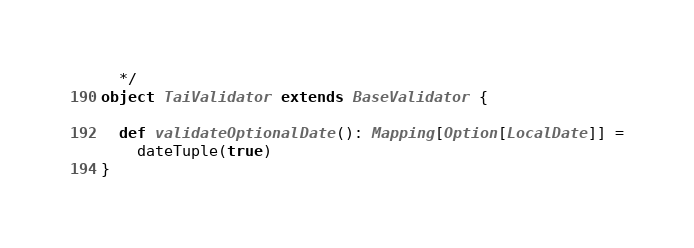Convert code to text. <code><loc_0><loc_0><loc_500><loc_500><_Scala_>  */
object TaiValidator extends BaseValidator {

  def validateOptionalDate(): Mapping[Option[LocalDate]] =
    dateTuple(true)
}
</code> 